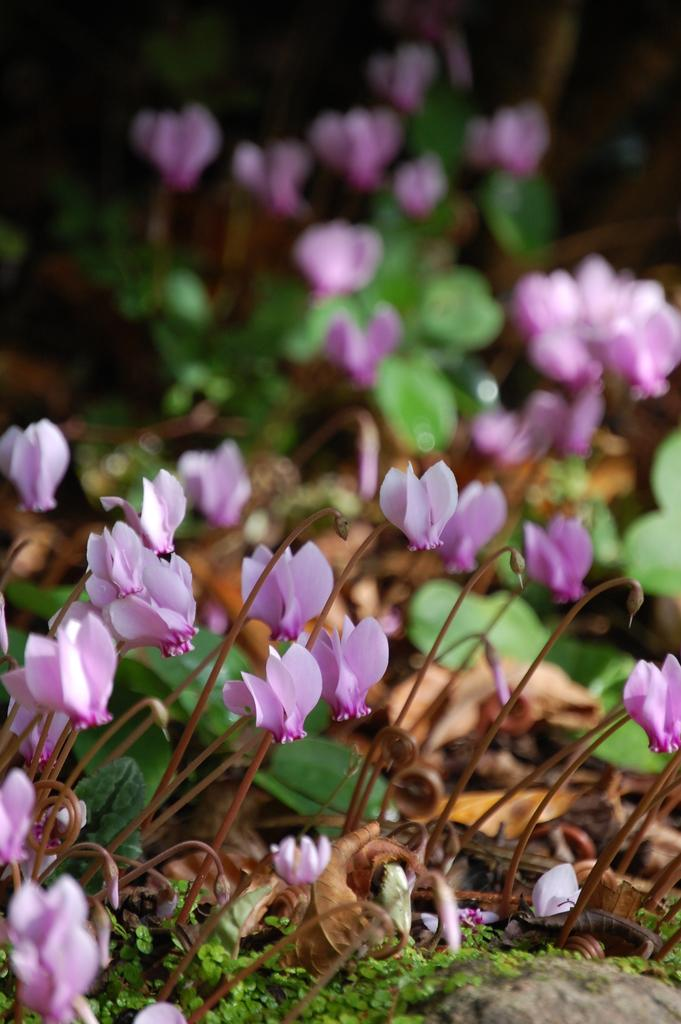What type of flora can be seen in the image? There are flowers and plants in the image. What color are the flowers in the image? The flowers are pink in color. How would you describe the color of the plants in the image? The plants are brown and green in color. Can you describe the background of the image? The background of the image is blurry. What type of baseball equipment can be seen in the image? There is no baseball equipment present in the image. What kind of boot is visible in the image? There is no boot present in the image. 